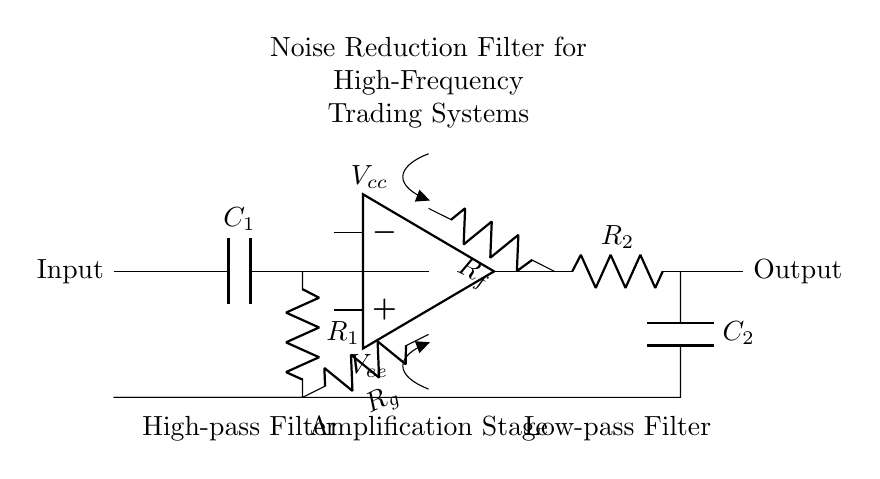What components are used in the high-pass filter stage? The high-pass filter stage consists of a capacitor (C1) and a resistor (R1). The capacitor blocks low frequencies while allowing high frequencies to pass through, and the resistor provides a path for the current.
Answer: Capacitor and resistor What is the role of the operational amplifier in this circuit? The operational amplifier amplifies the signal and helps improve the signal-to-noise ratio. It takes the input from the high-pass filter and provides a larger output signal, enhancing the filtering process.
Answer: Amplification What is the function of the feedback network in this noise reduction filter? The feedback network, composed of resistors Rf and Rg, enables the op-amp to stabilize the gain and control the frequency response. This configuration helps maintain the desired filtering characteristics by feeding back a portion of the output to the input.
Answer: Stabilize gain Which stage reduces low-frequency noise in this circuit? The low-pass filter stage, consisting of a resistor (R2) and a capacitor (C2), allows low frequencies to pass while filtering out higher frequencies, effectively reducing low-frequency noise that may interfere with high-frequency trading signals.
Answer: Low-pass filter What type of filter is implemented in this circuit? This circuit implements a combination of high-pass and low-pass filters forming a band-pass filter configuration, which simultaneously allows high frequencies to pass through while attenuating undesired low and high frequencies.
Answer: Band-pass filter 